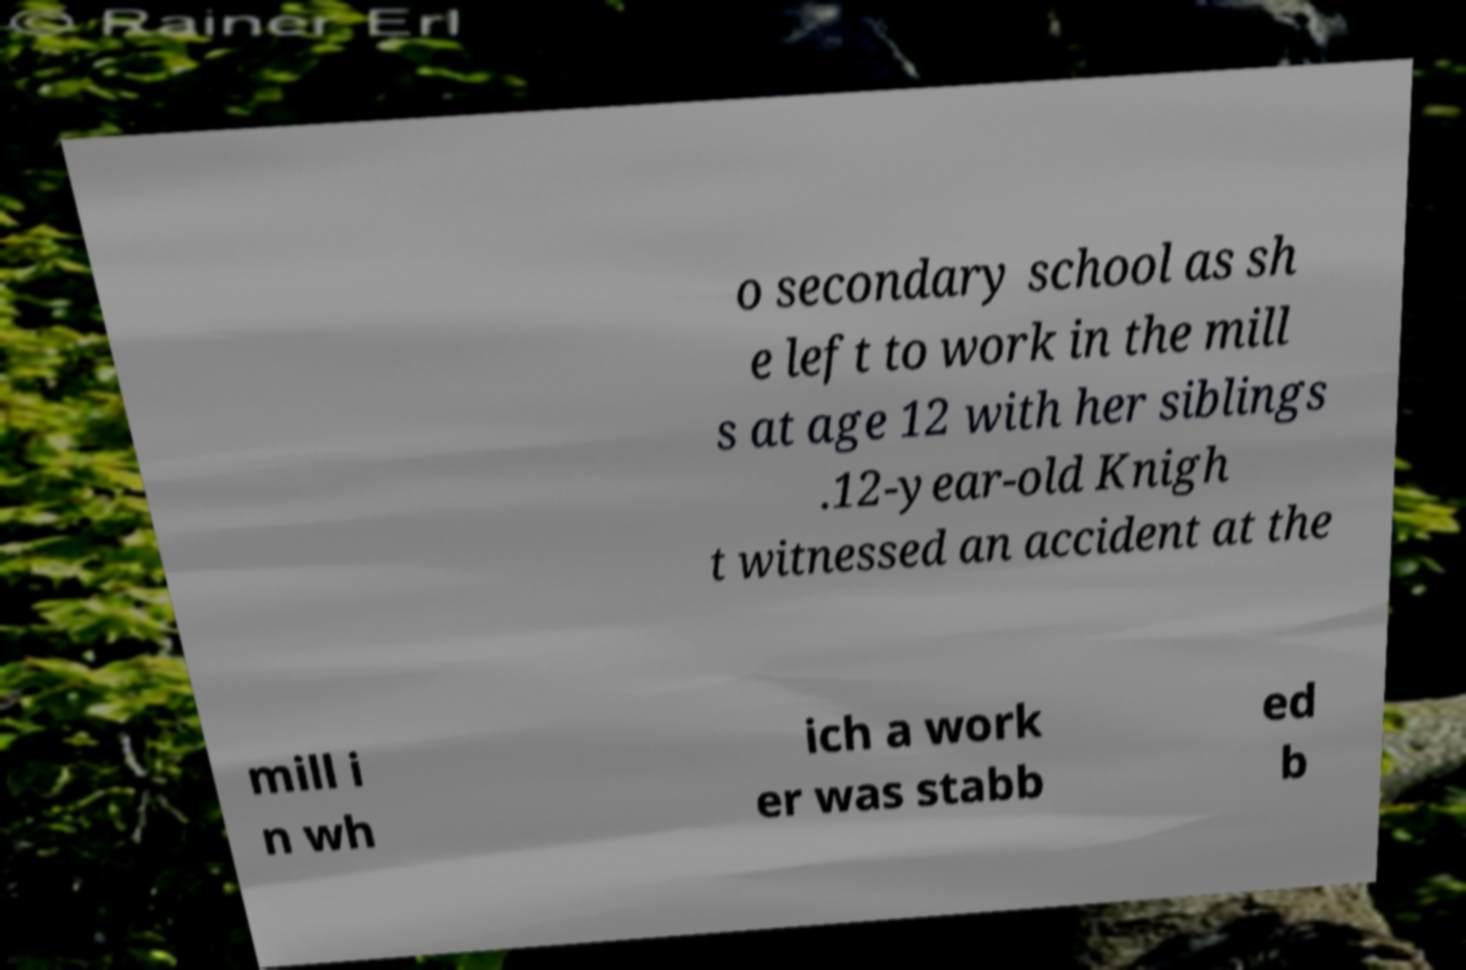Could you extract and type out the text from this image? o secondary school as sh e left to work in the mill s at age 12 with her siblings .12-year-old Knigh t witnessed an accident at the mill i n wh ich a work er was stabb ed b 